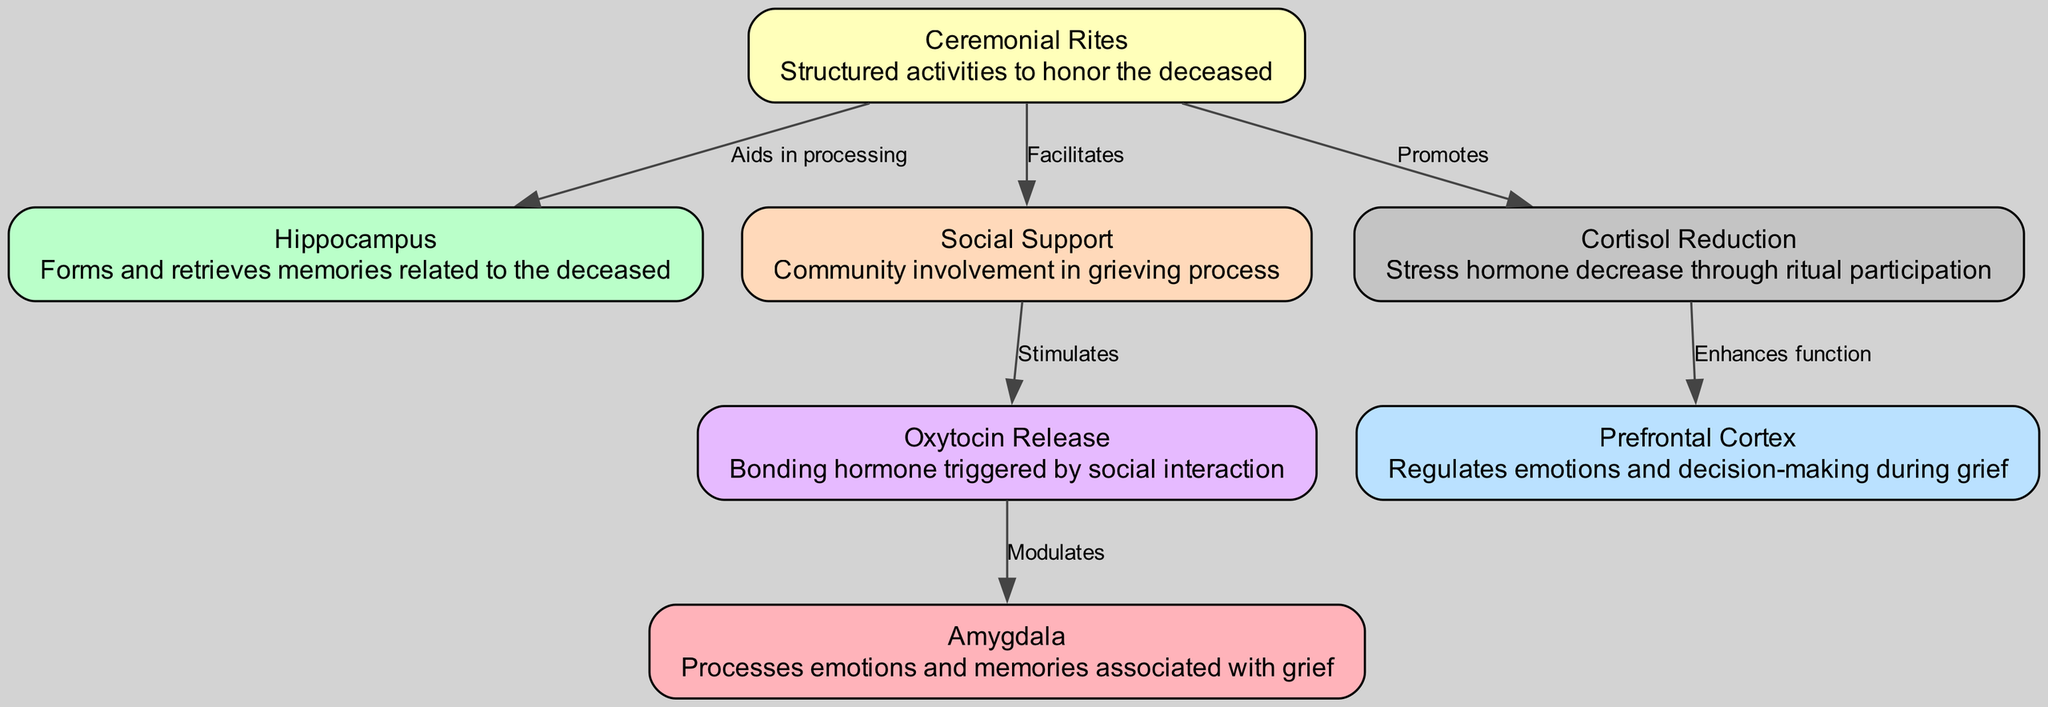What is the role of the amygdala in the context of grief? The amygdala processes emotions and memories associated with grief, as labeled in the diagram. It is connected to other aspects of the grieving process through its modulation of emotional responses.
Answer: Processes emotions and memories associated with grief How many nodes are present in the diagram? The diagram contains 7 nodes, which represent different components involved in the neurological processes of grief and ceremonial rites.
Answer: 7 What relationship does ceremonial rites have with social support? The diagram indicates that ceremonial rites facilitate social support, highlighting the role of structured activities in enhancing community involvement during grief.
Answer: Facilitates Which node is affected by cortisol reduction? The prefrontal cortex is affected by cortisol reduction, as the diagram shows a direct enhancement of its function due to decreased stress hormone levels through ritual participation.
Answer: Prefrontal Cortex How does oxytocin release interact with the amygdala? Oxytocin release modulates the amygdala, according to the diagram. This indicates that social interactions triggering oxytocin may influence emotional processing linked to grief.
Answer: Modulates What two nodes does the ceremonial rites aid in processing? The diagram specifies that ceremonial rites aid in processing both hippocampus and amygdala, supporting their roles in memory retrieval and emotional processing related to grief.
Answer: Hippocampus and Amygdala How many edges connect to the hippocampus? There are two edges that connect to the hippocampus. One from ceremonial rites, which aids in processing memories, and another from cortisol reduction, enhancing the prefrontal cortex's function.
Answer: 2 